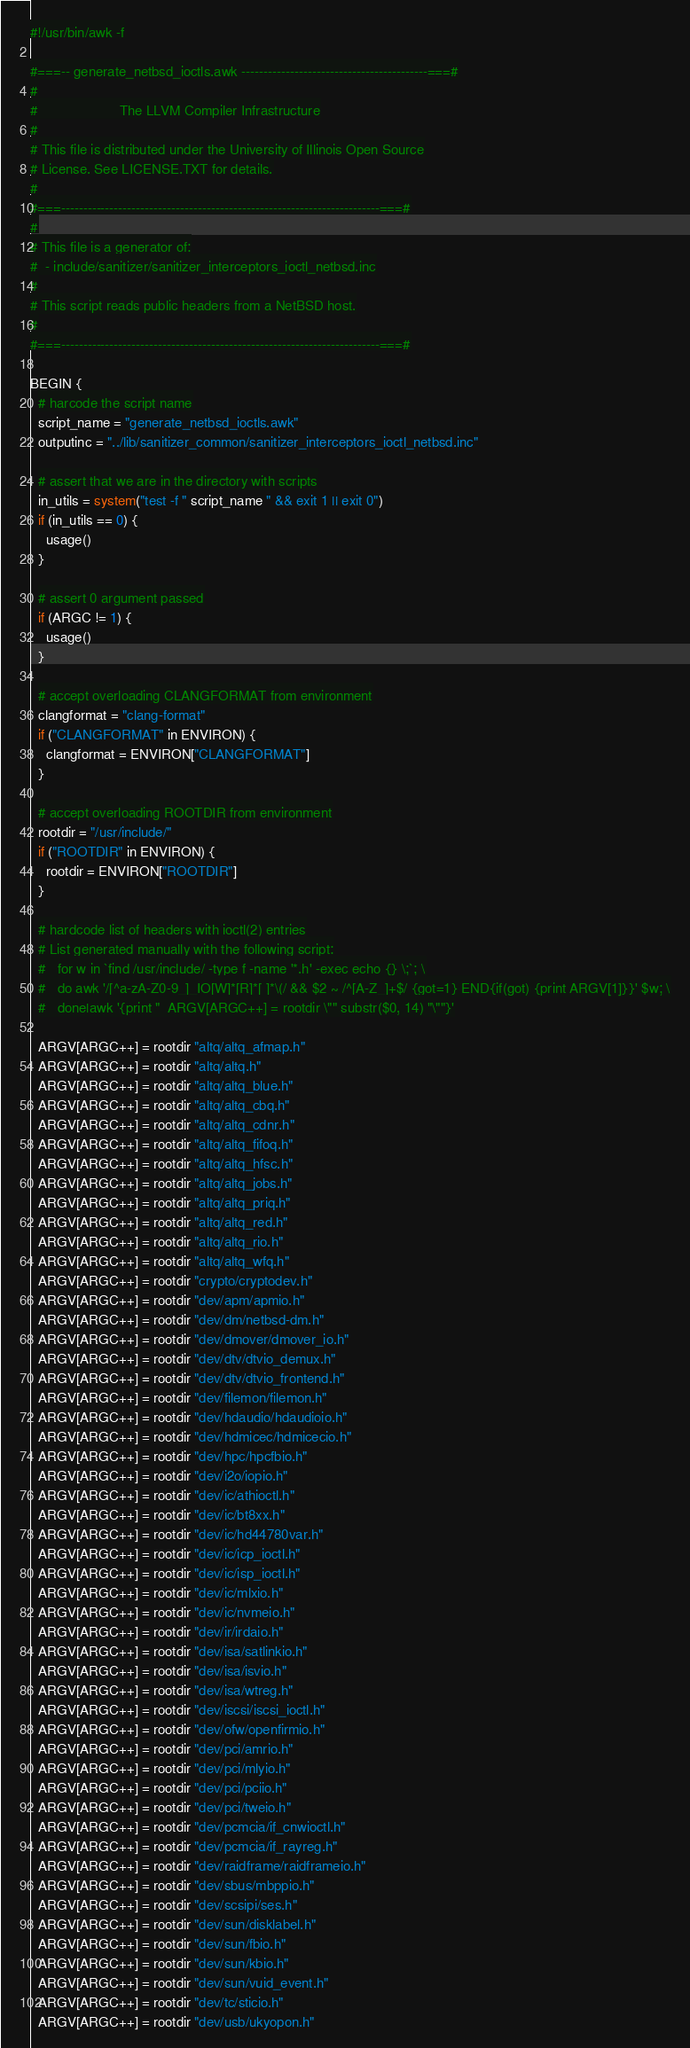<code> <loc_0><loc_0><loc_500><loc_500><_Awk_>#!/usr/bin/awk -f

#===-- generate_netbsd_ioctls.awk ------------------------------------------===#
#
#                     The LLVM Compiler Infrastructure
#
# This file is distributed under the University of Illinois Open Source
# License. See LICENSE.TXT for details.
#
#===------------------------------------------------------------------------===#
#
# This file is a generator of:
#  - include/sanitizer/sanitizer_interceptors_ioctl_netbsd.inc
#
# This script reads public headers from a NetBSD host.
#
#===------------------------------------------------------------------------===#

BEGIN {
  # harcode the script name
  script_name = "generate_netbsd_ioctls.awk"
  outputinc = "../lib/sanitizer_common/sanitizer_interceptors_ioctl_netbsd.inc"

  # assert that we are in the directory with scripts
  in_utils = system("test -f " script_name " && exit 1 || exit 0")
  if (in_utils == 0) {
    usage()
  }

  # assert 0 argument passed
  if (ARGC != 1) {
    usage()
  }

  # accept overloading CLANGFORMAT from environment
  clangformat = "clang-format"
  if ("CLANGFORMAT" in ENVIRON) {
    clangformat = ENVIRON["CLANGFORMAT"]
  }

  # accept overloading ROOTDIR from environment
  rootdir = "/usr/include/"
  if ("ROOTDIR" in ENVIRON) {
    rootdir = ENVIRON["ROOTDIR"]
  }

  # hardcode list of headers with ioctl(2) entries
  # List generated manually with the following script:
  #   for w in `find /usr/include/ -type f -name '*.h' -exec echo {} \;`; \
  #   do awk '/[^a-zA-Z0-9_]_IO[W]*[R]*[ ]*\(/ && $2 ~ /^[A-Z_]+$/ {got=1} END{if(got) {print ARGV[1]}}' $w; \
  #   done|awk '{print "  ARGV[ARGC++] = rootdir \"" substr($0, 14) "\""}'

  ARGV[ARGC++] = rootdir "altq/altq_afmap.h"
  ARGV[ARGC++] = rootdir "altq/altq.h"
  ARGV[ARGC++] = rootdir "altq/altq_blue.h"
  ARGV[ARGC++] = rootdir "altq/altq_cbq.h"
  ARGV[ARGC++] = rootdir "altq/altq_cdnr.h"
  ARGV[ARGC++] = rootdir "altq/altq_fifoq.h"
  ARGV[ARGC++] = rootdir "altq/altq_hfsc.h"
  ARGV[ARGC++] = rootdir "altq/altq_jobs.h"
  ARGV[ARGC++] = rootdir "altq/altq_priq.h"
  ARGV[ARGC++] = rootdir "altq/altq_red.h"
  ARGV[ARGC++] = rootdir "altq/altq_rio.h"
  ARGV[ARGC++] = rootdir "altq/altq_wfq.h"
  ARGV[ARGC++] = rootdir "crypto/cryptodev.h"
  ARGV[ARGC++] = rootdir "dev/apm/apmio.h"
  ARGV[ARGC++] = rootdir "dev/dm/netbsd-dm.h"
  ARGV[ARGC++] = rootdir "dev/dmover/dmover_io.h"
  ARGV[ARGC++] = rootdir "dev/dtv/dtvio_demux.h"
  ARGV[ARGC++] = rootdir "dev/dtv/dtvio_frontend.h"
  ARGV[ARGC++] = rootdir "dev/filemon/filemon.h"
  ARGV[ARGC++] = rootdir "dev/hdaudio/hdaudioio.h"
  ARGV[ARGC++] = rootdir "dev/hdmicec/hdmicecio.h"
  ARGV[ARGC++] = rootdir "dev/hpc/hpcfbio.h"
  ARGV[ARGC++] = rootdir "dev/i2o/iopio.h"
  ARGV[ARGC++] = rootdir "dev/ic/athioctl.h"
  ARGV[ARGC++] = rootdir "dev/ic/bt8xx.h"
  ARGV[ARGC++] = rootdir "dev/ic/hd44780var.h"
  ARGV[ARGC++] = rootdir "dev/ic/icp_ioctl.h"
  ARGV[ARGC++] = rootdir "dev/ic/isp_ioctl.h"
  ARGV[ARGC++] = rootdir "dev/ic/mlxio.h"
  ARGV[ARGC++] = rootdir "dev/ic/nvmeio.h"
  ARGV[ARGC++] = rootdir "dev/ir/irdaio.h"
  ARGV[ARGC++] = rootdir "dev/isa/satlinkio.h"
  ARGV[ARGC++] = rootdir "dev/isa/isvio.h"
  ARGV[ARGC++] = rootdir "dev/isa/wtreg.h"
  ARGV[ARGC++] = rootdir "dev/iscsi/iscsi_ioctl.h"
  ARGV[ARGC++] = rootdir "dev/ofw/openfirmio.h"
  ARGV[ARGC++] = rootdir "dev/pci/amrio.h"
  ARGV[ARGC++] = rootdir "dev/pci/mlyio.h"
  ARGV[ARGC++] = rootdir "dev/pci/pciio.h"
  ARGV[ARGC++] = rootdir "dev/pci/tweio.h"
  ARGV[ARGC++] = rootdir "dev/pcmcia/if_cnwioctl.h"
  ARGV[ARGC++] = rootdir "dev/pcmcia/if_rayreg.h"
  ARGV[ARGC++] = rootdir "dev/raidframe/raidframeio.h"
  ARGV[ARGC++] = rootdir "dev/sbus/mbppio.h"
  ARGV[ARGC++] = rootdir "dev/scsipi/ses.h"
  ARGV[ARGC++] = rootdir "dev/sun/disklabel.h"
  ARGV[ARGC++] = rootdir "dev/sun/fbio.h"
  ARGV[ARGC++] = rootdir "dev/sun/kbio.h"
  ARGV[ARGC++] = rootdir "dev/sun/vuid_event.h"
  ARGV[ARGC++] = rootdir "dev/tc/sticio.h"
  ARGV[ARGC++] = rootdir "dev/usb/ukyopon.h"</code> 